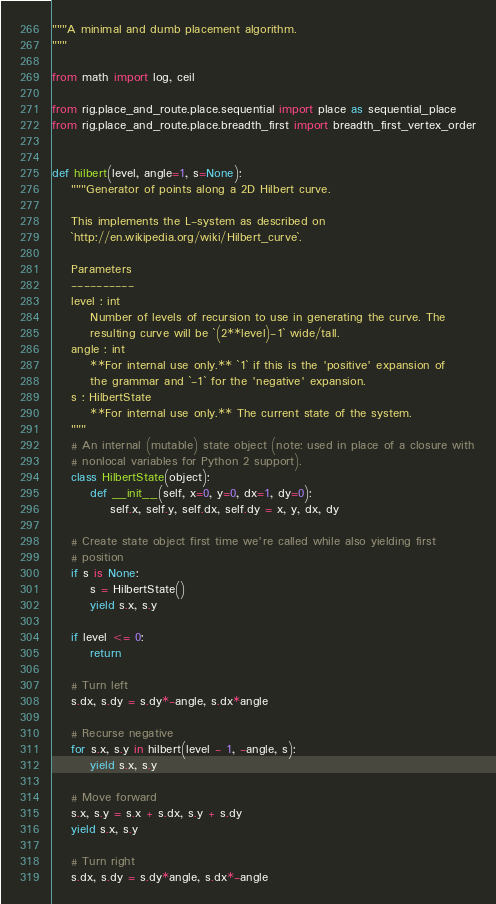Convert code to text. <code><loc_0><loc_0><loc_500><loc_500><_Python_>"""A minimal and dumb placement algorithm.
"""

from math import log, ceil

from rig.place_and_route.place.sequential import place as sequential_place
from rig.place_and_route.place.breadth_first import breadth_first_vertex_order


def hilbert(level, angle=1, s=None):
    """Generator of points along a 2D Hilbert curve.

    This implements the L-system as described on
    `http://en.wikipedia.org/wiki/Hilbert_curve`.

    Parameters
    ----------
    level : int
        Number of levels of recursion to use in generating the curve. The
        resulting curve will be `(2**level)-1` wide/tall.
    angle : int
        **For internal use only.** `1` if this is the 'positive' expansion of
        the grammar and `-1` for the 'negative' expansion.
    s : HilbertState
        **For internal use only.** The current state of the system.
    """
    # An internal (mutable) state object (note: used in place of a closure with
    # nonlocal variables for Python 2 support).
    class HilbertState(object):
        def __init__(self, x=0, y=0, dx=1, dy=0):
            self.x, self.y, self.dx, self.dy = x, y, dx, dy

    # Create state object first time we're called while also yielding first
    # position
    if s is None:
        s = HilbertState()
        yield s.x, s.y

    if level <= 0:
        return

    # Turn left
    s.dx, s.dy = s.dy*-angle, s.dx*angle

    # Recurse negative
    for s.x, s.y in hilbert(level - 1, -angle, s):
        yield s.x, s.y

    # Move forward
    s.x, s.y = s.x + s.dx, s.y + s.dy
    yield s.x, s.y

    # Turn right
    s.dx, s.dy = s.dy*angle, s.dx*-angle
</code> 